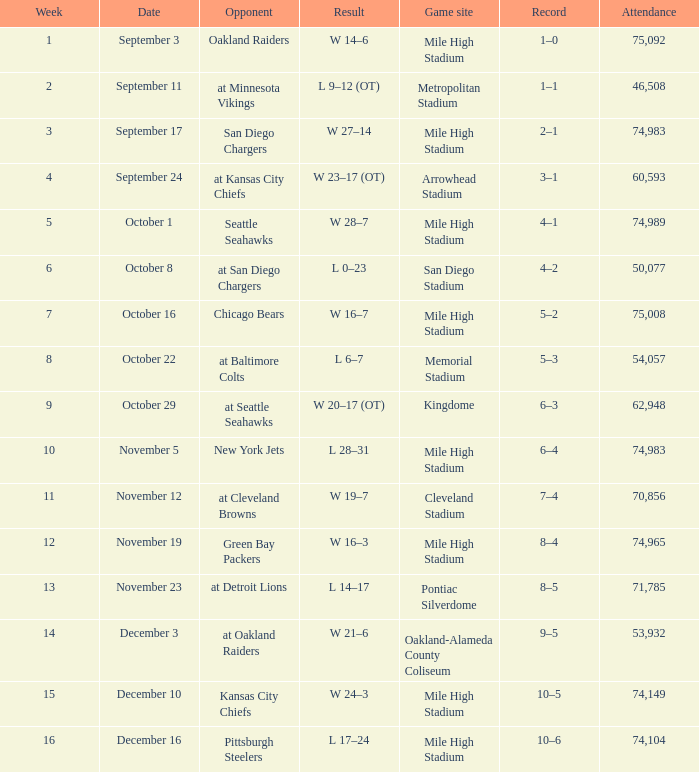When was the result 28-7 recorded? October 1. 